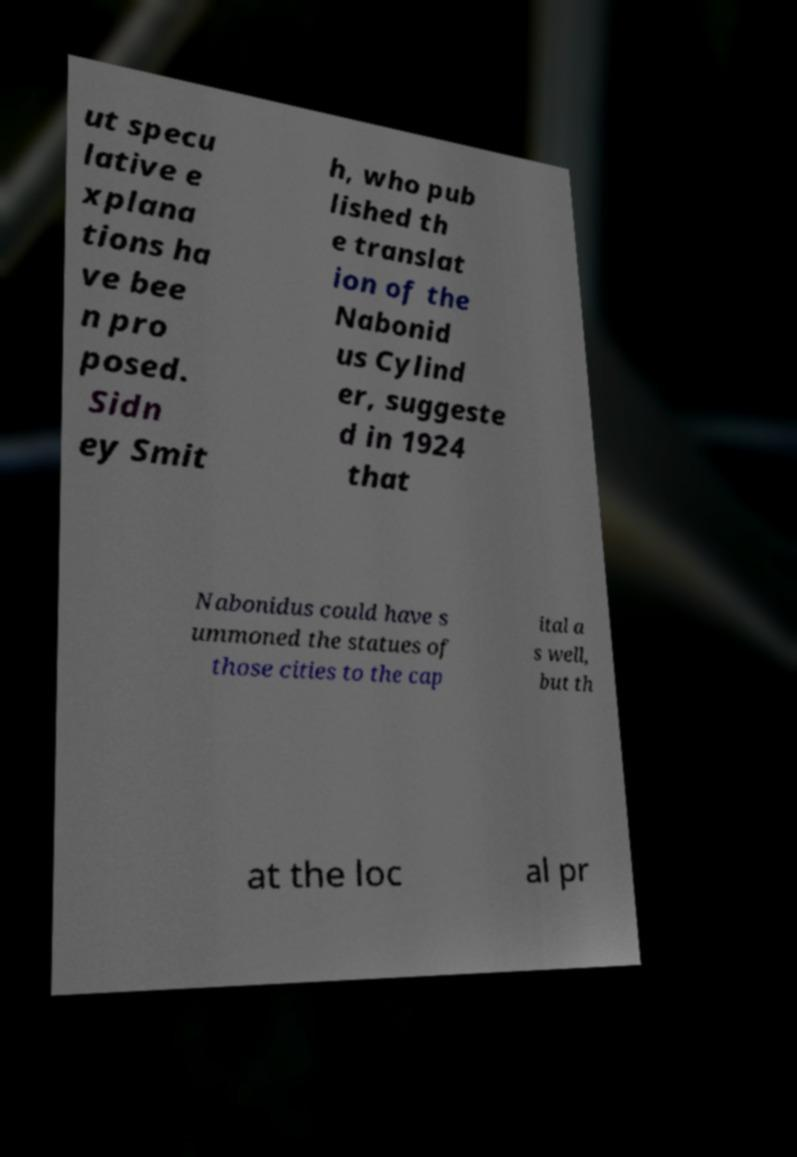Could you assist in decoding the text presented in this image and type it out clearly? ut specu lative e xplana tions ha ve bee n pro posed. Sidn ey Smit h, who pub lished th e translat ion of the Nabonid us Cylind er, suggeste d in 1924 that Nabonidus could have s ummoned the statues of those cities to the cap ital a s well, but th at the loc al pr 